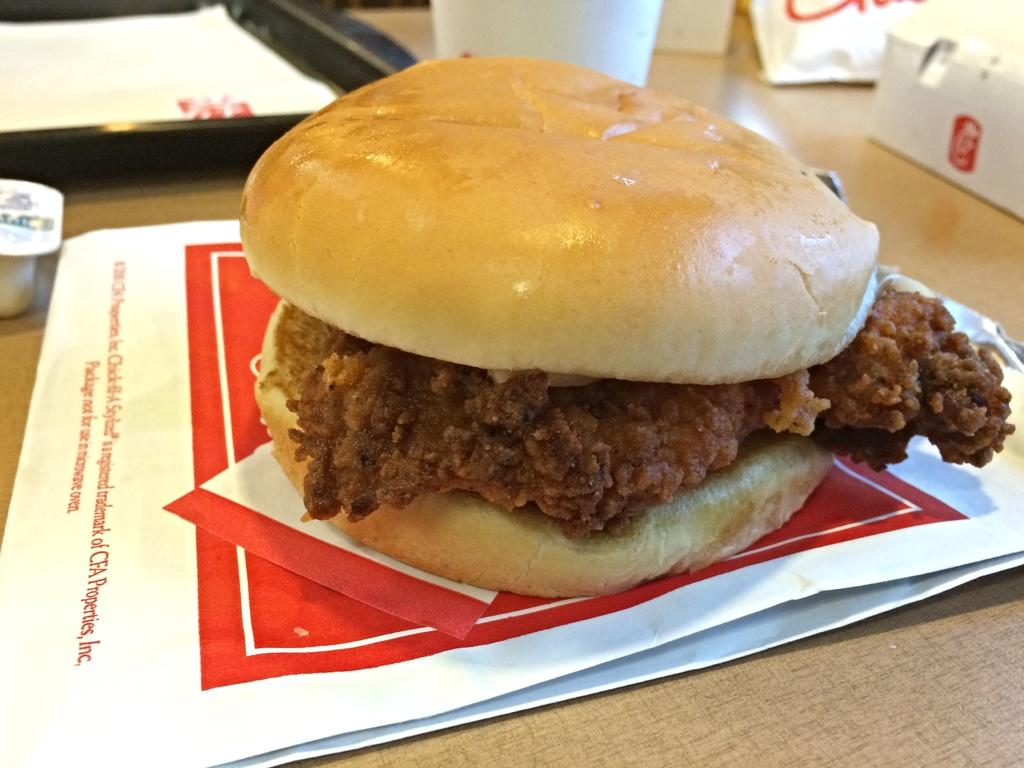What is the main object in the center of the image? There is a table in the center of the image. What type of food can be seen on the table? A burger is present on the table. What else is on the table besides the burger? There is a paper, a plate, a glass, and a box on the table. Can you see a giraffe eating the burger in the image? No, there is no giraffe present in the image. 